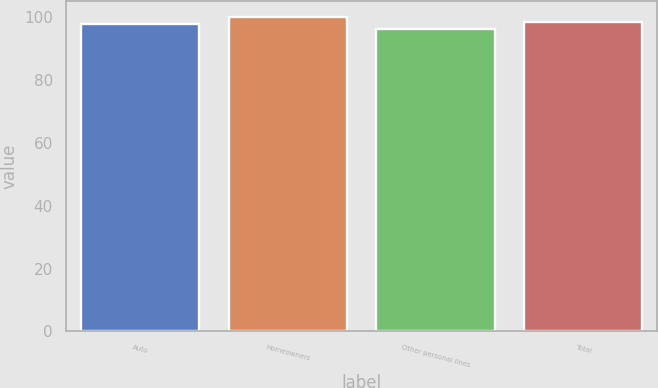<chart> <loc_0><loc_0><loc_500><loc_500><bar_chart><fcel>Auto<fcel>Homeowners<fcel>Other personal lines<fcel>Total<nl><fcel>98<fcel>100.2<fcel>96.4<fcel>98.7<nl></chart> 